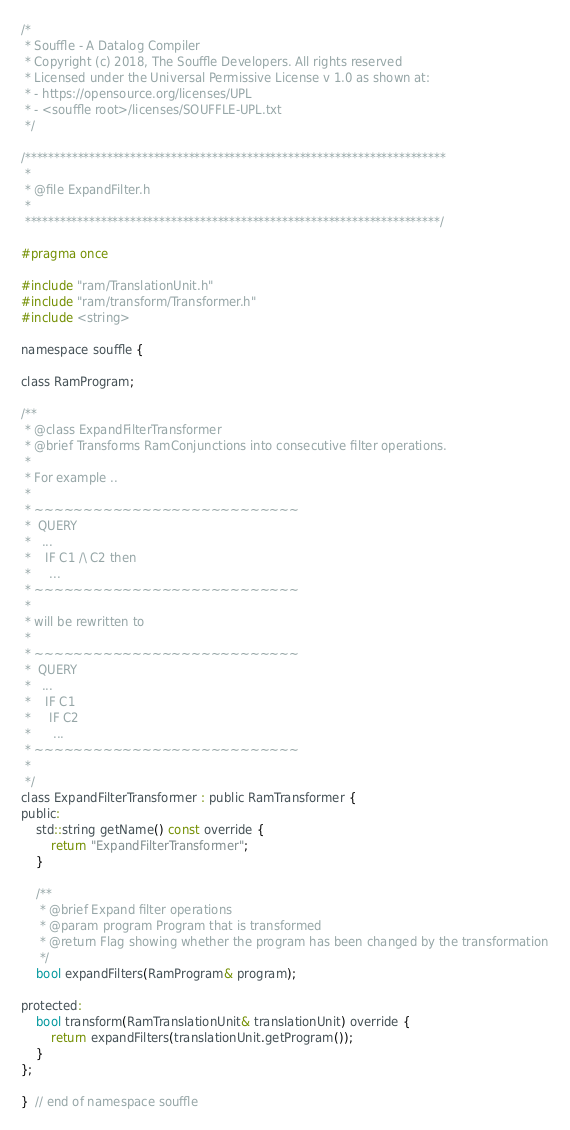<code> <loc_0><loc_0><loc_500><loc_500><_C_>/*
 * Souffle - A Datalog Compiler
 * Copyright (c) 2018, The Souffle Developers. All rights reserved
 * Licensed under the Universal Permissive License v 1.0 as shown at:
 * - https://opensource.org/licenses/UPL
 * - <souffle root>/licenses/SOUFFLE-UPL.txt
 */

/************************************************************************
 *
 * @file ExpandFilter.h
 *
 ***********************************************************************/

#pragma once

#include "ram/TranslationUnit.h"
#include "ram/transform/Transformer.h"
#include <string>

namespace souffle {

class RamProgram;

/**
 * @class ExpandFilterTransformer
 * @brief Transforms RamConjunctions into consecutive filter operations.
 *
 * For example ..
 *
 * ~~~~~~~~~~~~~~~~~~~~~~~~~~~
 *  QUERY
 *   ...
 *    IF C1 /\ C2 then
 *     ...
 * ~~~~~~~~~~~~~~~~~~~~~~~~~~~
 *
 * will be rewritten to
 *
 * ~~~~~~~~~~~~~~~~~~~~~~~~~~~
 *  QUERY
 *   ...
 *    IF C1
 *     IF C2
 *      ...
 * ~~~~~~~~~~~~~~~~~~~~~~~~~~~
 *
 */
class ExpandFilterTransformer : public RamTransformer {
public:
    std::string getName() const override {
        return "ExpandFilterTransformer";
    }

    /**
     * @brief Expand filter operations
     * @param program Program that is transformed
     * @return Flag showing whether the program has been changed by the transformation
     */
    bool expandFilters(RamProgram& program);

protected:
    bool transform(RamTranslationUnit& translationUnit) override {
        return expandFilters(translationUnit.getProgram());
    }
};

}  // end of namespace souffle
</code> 